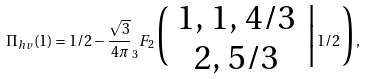Convert formula to latex. <formula><loc_0><loc_0><loc_500><loc_500>\Pi _ { h v } ( 1 ) = 1 / 2 - \frac { \sqrt { 3 } } { 4 \pi } _ { 3 } F _ { 2 } \Big ( \begin{array} { c } { 1 , \, 1 , \, 4 / 3 } \\ { 2 , \, 5 / 3 } \\ \end{array} \, \Big | 1 / 2 \, \Big ) ,</formula> 